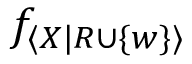Convert formula to latex. <formula><loc_0><loc_0><loc_500><loc_500>f _ { \langle X | R \cup \{ w \} \rangle }</formula> 